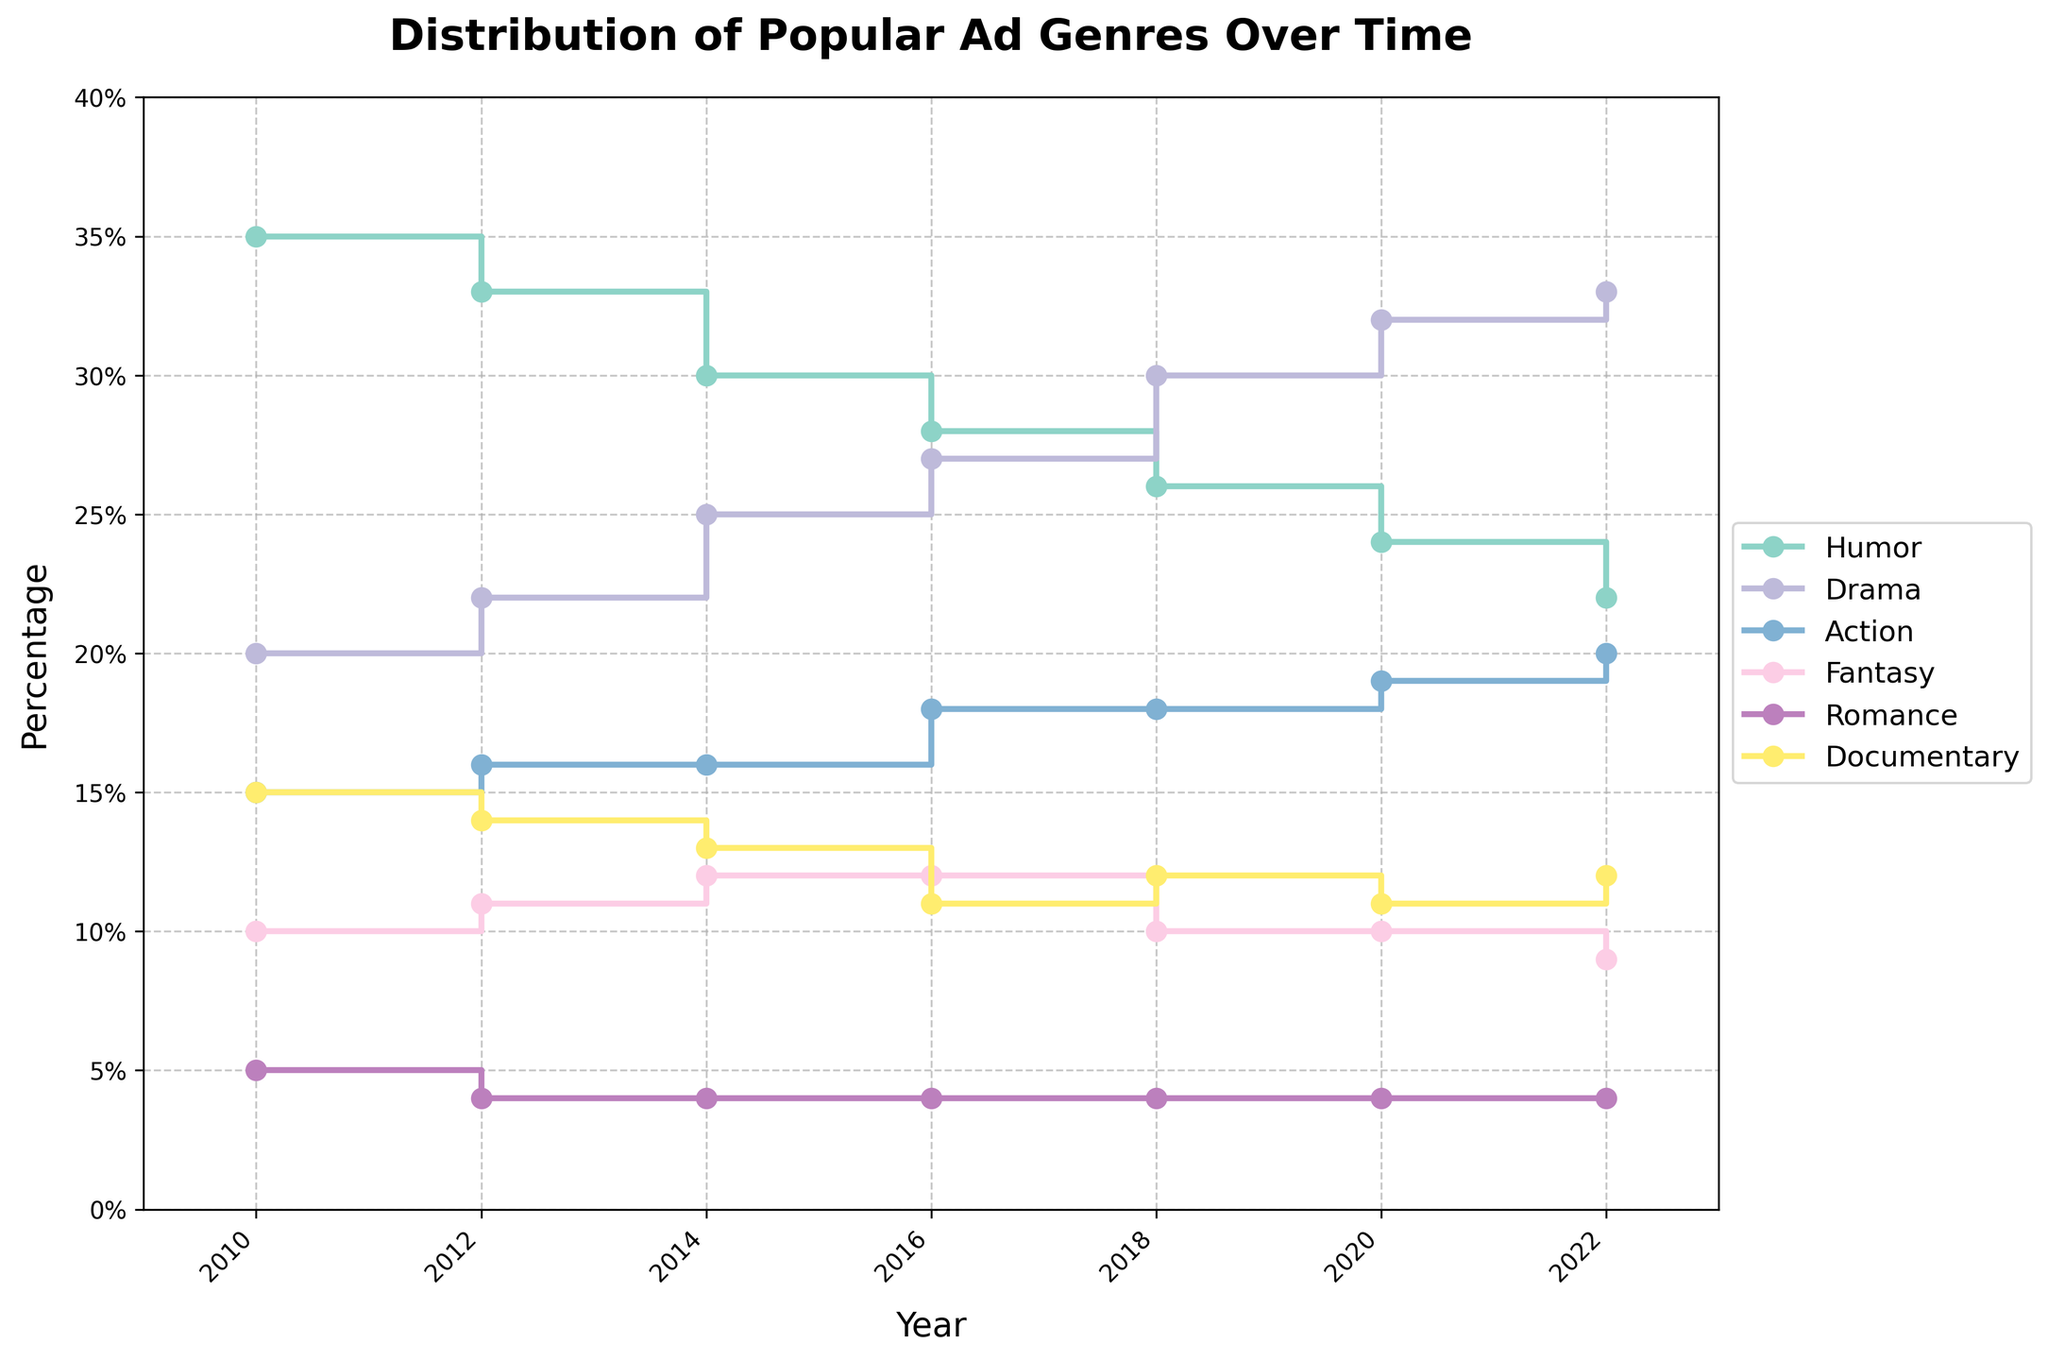Which ad genre had the highest percentage in 2022? The figure shows the percentage distribution of different ad genres over several years. In 2022, "Drama" had the highest percentage.
Answer: Drama What is the overall trend for the Humor genre from 2010 to 2022? The percentage of Humor ads steadily declined from 35% in 2010 to 22% in 2022. This suggests a decreasing trend over the years.
Answer: Decreasing By how many percentage points did the Documentary genre percentage change from 2010 to 2022? In 2010, the Documentary genre was at 15%, while in 2022, it was at 12%. The change is 15% - 12% = 3%.
Answer: 3% Which genre saw the largest increase in percentage from 2010 to 2022? By examining the differences between percentages in 2010 and 2022 for each genre, Drama increased from 20% to 33%, which is the largest increase of 13%.
Answer: Drama Which genre consistently had the smallest percentage from 2010 to 2022? The Romance genre consistently had the smallest percentage, spanning from 4% to 5% throughout the years from 2010 to 2022.
Answer: Romance Between which years did the Action genre see its highest increase in percentage? From examining the trend line, Action saw its highest increase from 2010 (15%) to 2016 (18%), making a 3% increase.
Answer: 2010 to 2016 What was the percentage difference between Humor and Drama genres in 2020? In 2020, Humor was at 24% and Drama was at 32%. Their percentage difference is 32% - 24% = 8%.
Answer: 8% Which genre showed the most stability over the years? The Romance genre showed the most stability, maintaining a percentage between 4% and 5% consistently from 2010 to 2022.
Answer: Romance At which year did Drama surpass Humor in percentage? Drama surpassed Humor in 2018, with Drama at 30% and Humor at 26%.
Answer: 2018 